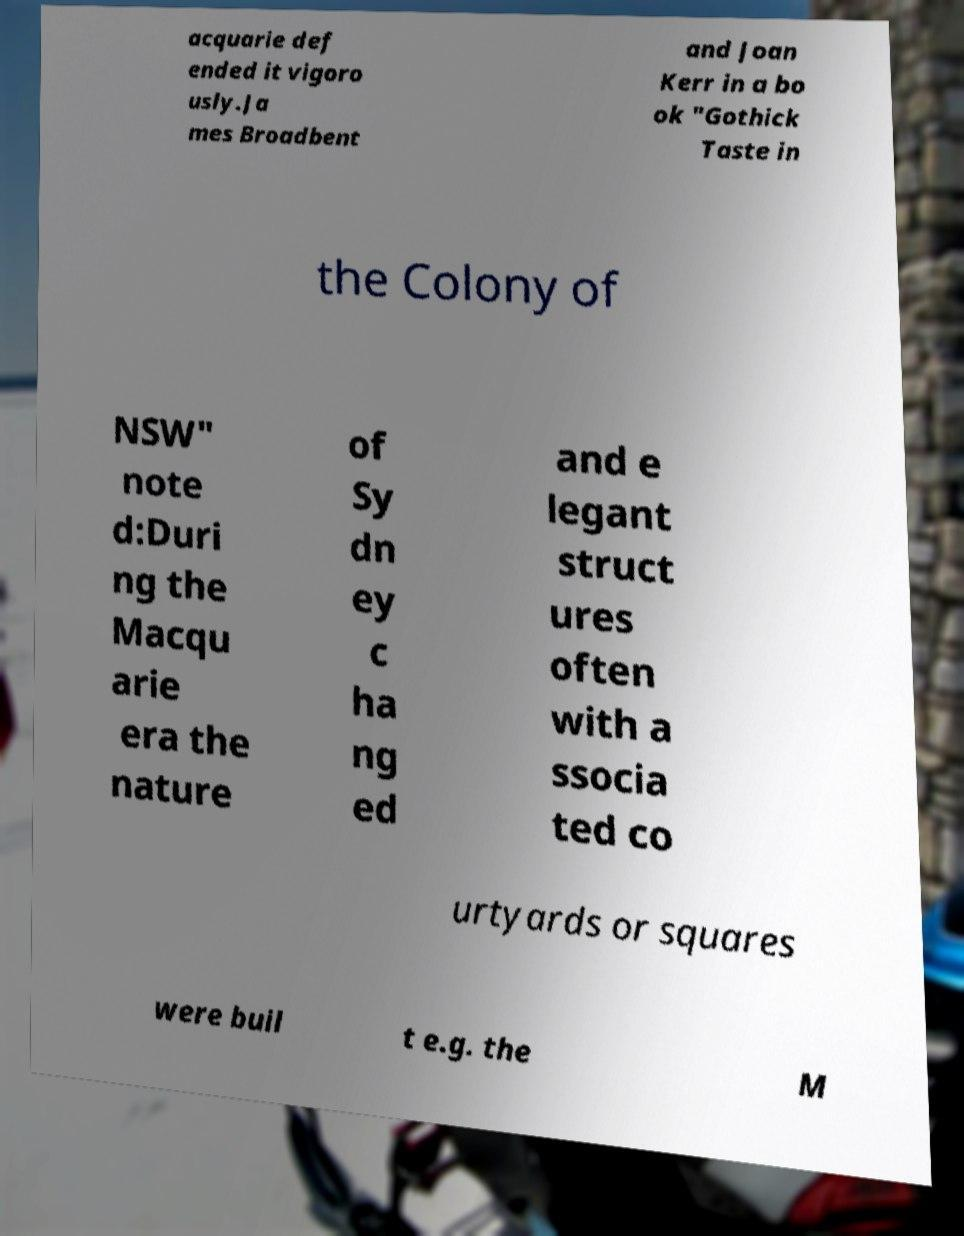For documentation purposes, I need the text within this image transcribed. Could you provide that? acquarie def ended it vigoro usly.Ja mes Broadbent and Joan Kerr in a bo ok "Gothick Taste in the Colony of NSW" note d:Duri ng the Macqu arie era the nature of Sy dn ey c ha ng ed and e legant struct ures often with a ssocia ted co urtyards or squares were buil t e.g. the M 